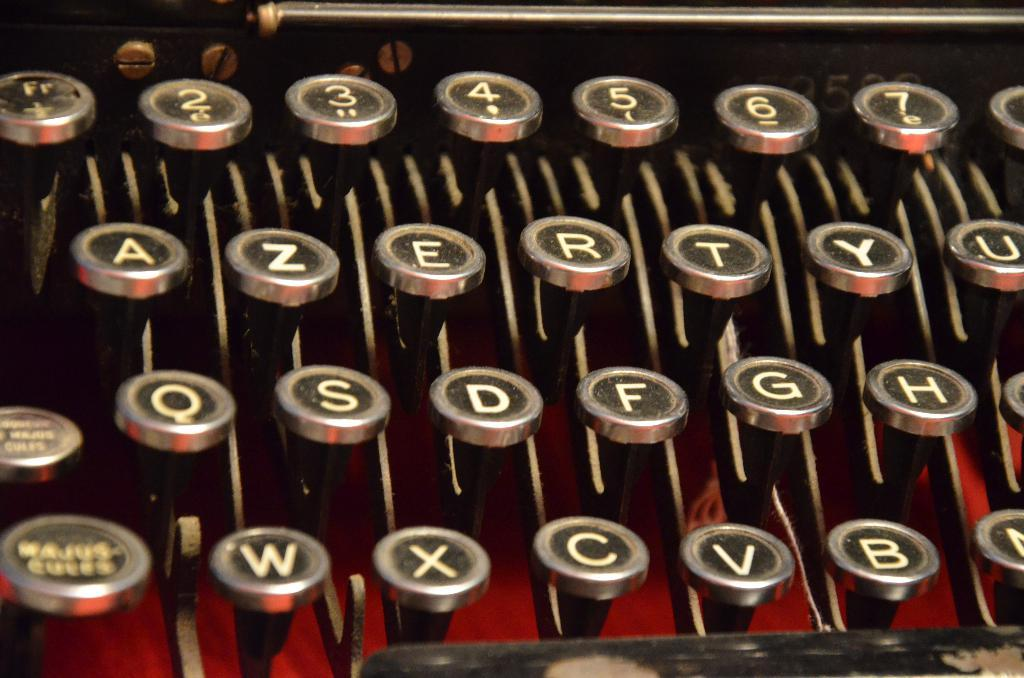<image>
Create a compact narrative representing the image presented. an old typewriter keys from A - U on the top row down to W - B on the bottom 